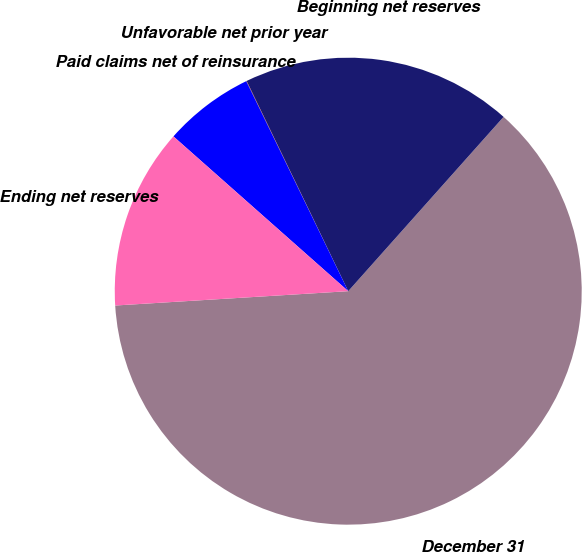<chart> <loc_0><loc_0><loc_500><loc_500><pie_chart><fcel>December 31<fcel>Beginning net reserves<fcel>Unfavorable net prior year<fcel>Paid claims net of reinsurance<fcel>Ending net reserves<nl><fcel>62.43%<fcel>18.75%<fcel>0.03%<fcel>6.27%<fcel>12.51%<nl></chart> 